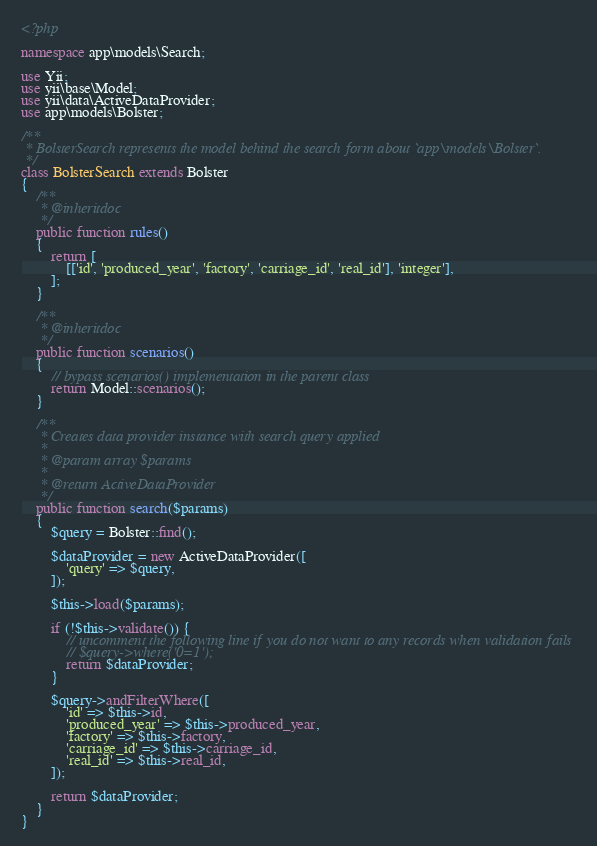Convert code to text. <code><loc_0><loc_0><loc_500><loc_500><_PHP_><?php

namespace app\models\Search;

use Yii;
use yii\base\Model;
use yii\data\ActiveDataProvider;
use app\models\Bolster;

/**
 * BolsterSearch represents the model behind the search form about `app\models\Bolster`.
 */
class BolsterSearch extends Bolster
{
    /**
     * @inheritdoc
     */
    public function rules()
    {
        return [
            [['id', 'produced_year', 'factory', 'carriage_id', 'real_id'], 'integer'],
        ];
    }

    /**
     * @inheritdoc
     */
    public function scenarios()
    {
        // bypass scenarios() implementation in the parent class
        return Model::scenarios();
    }

    /**
     * Creates data provider instance with search query applied
     *
     * @param array $params
     *
     * @return ActiveDataProvider
     */
    public function search($params)
    {
        $query = Bolster::find();

        $dataProvider = new ActiveDataProvider([
            'query' => $query,
        ]);

        $this->load($params);

        if (!$this->validate()) {
            // uncomment the following line if you do not want to any records when validation fails
            // $query->where('0=1');
            return $dataProvider;
        }

        $query->andFilterWhere([
            'id' => $this->id,
            'produced_year' => $this->produced_year,
            'factory' => $this->factory,
            'carriage_id' => $this->carriage_id,
            'real_id' => $this->real_id,
        ]);

        return $dataProvider;
    }
}
</code> 